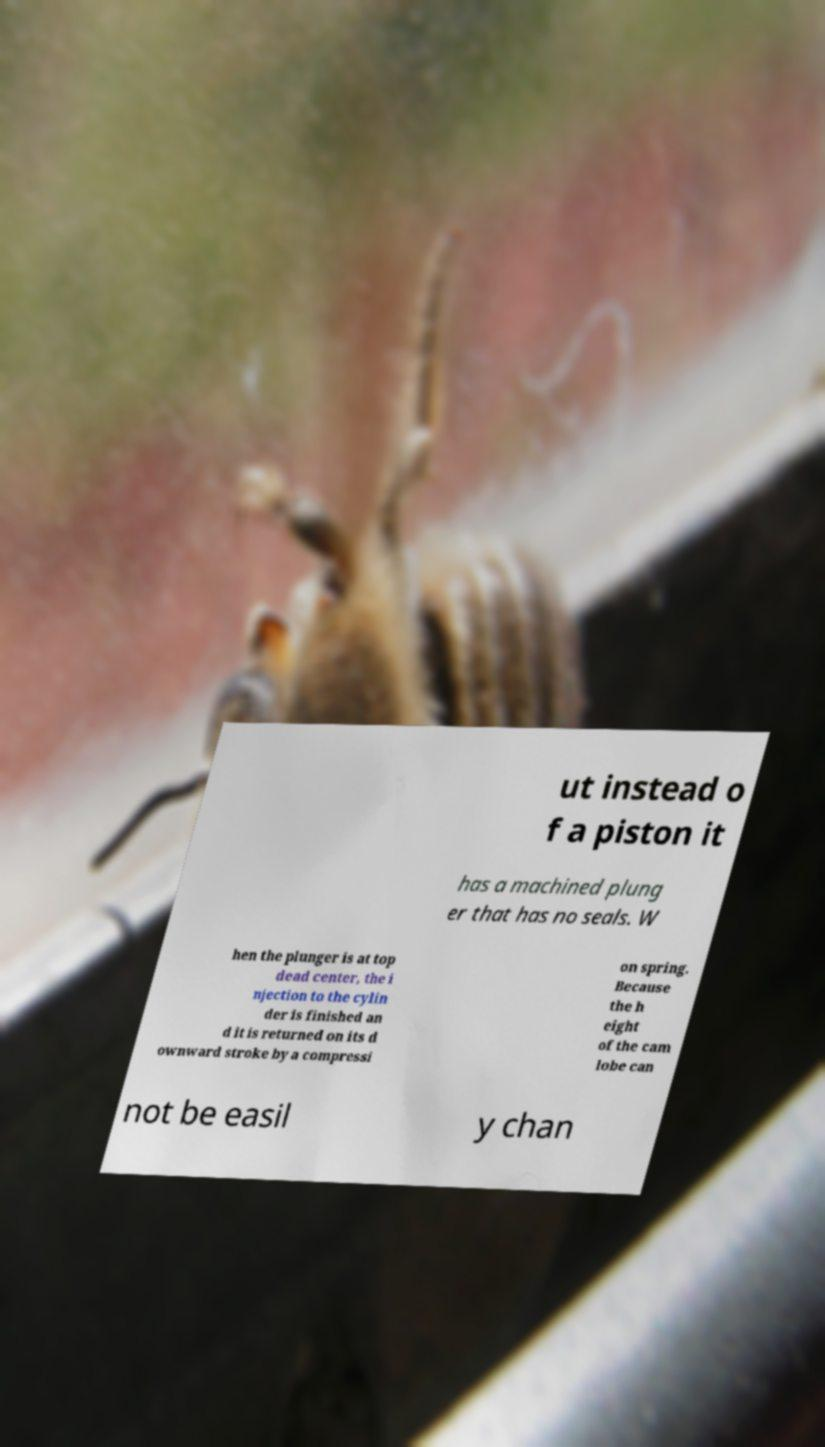What messages or text are displayed in this image? I need them in a readable, typed format. ut instead o f a piston it has a machined plung er that has no seals. W hen the plunger is at top dead center, the i njection to the cylin der is finished an d it is returned on its d ownward stroke by a compressi on spring. Because the h eight of the cam lobe can not be easil y chan 